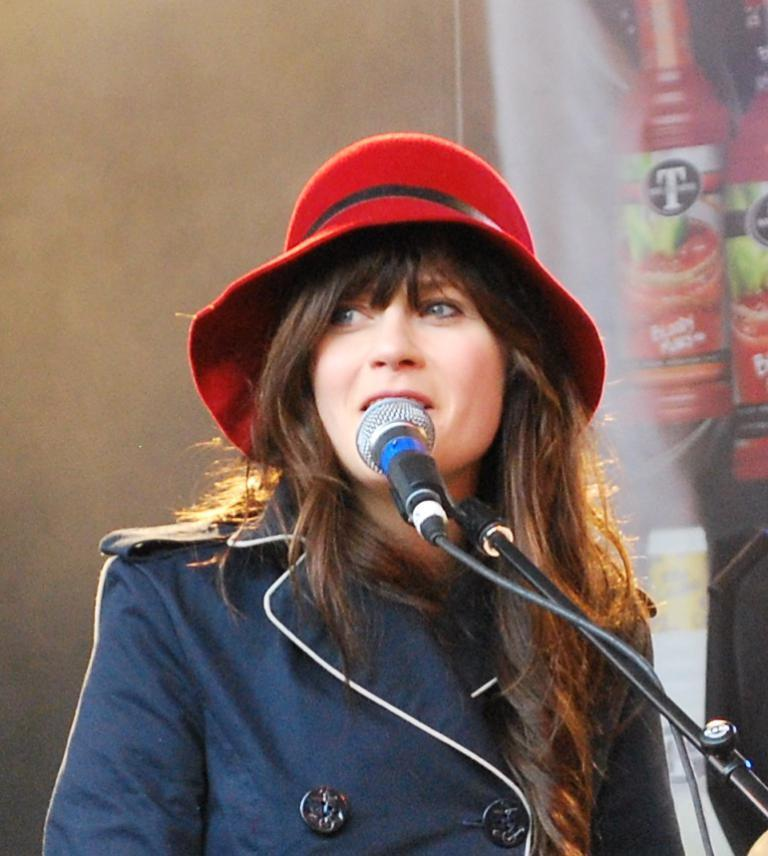Who is the main subject in the image? There is a girl in the middle of the image. What is the girl doing in the image? The girl is in front of a mic. What can be seen in the background of the image? There is a banner in the background of the image. What is the girl wearing on her head? The girl is wearing a red-colored hat. Can you hear the dog barking in the image? There is no dog present in the image, so it is not possible to hear any barking. 